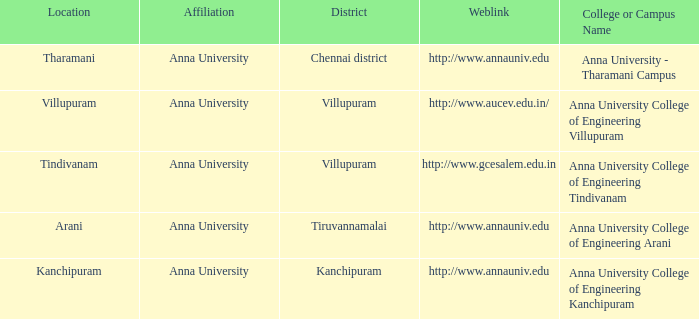What Location has a College or Campus Name of anna university - tharamani campus? Tharamani. 